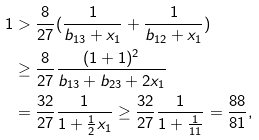<formula> <loc_0><loc_0><loc_500><loc_500>1 & > \frac { 8 } { 2 7 } ( \frac { 1 } { b _ { 1 3 } + x _ { 1 } } + \frac { 1 } { b _ { 1 2 } + x _ { 1 } } ) \\ & \geq \frac { 8 } { 2 7 } \frac { ( 1 + 1 ) ^ { 2 } } { b _ { 1 3 } + b _ { 2 3 } + 2 x _ { 1 } } \\ & = \frac { 3 2 } { 2 7 } \frac { 1 } { 1 + \frac { 1 } { 2 } x _ { 1 } } \geq \frac { 3 2 } { 2 7 } \frac { 1 } { 1 + \frac { 1 } { 1 1 } } = \frac { 8 8 } { 8 1 } ,</formula> 